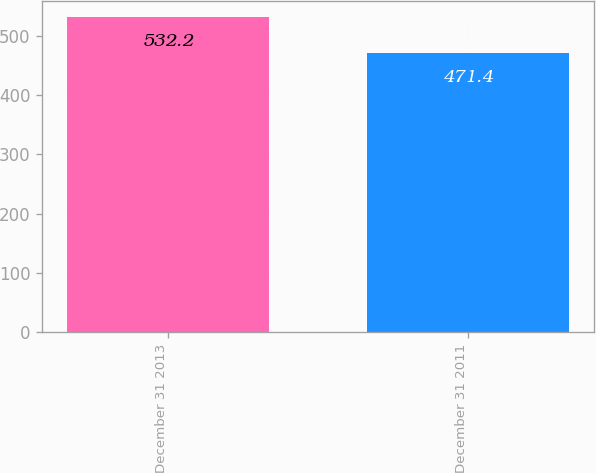<chart> <loc_0><loc_0><loc_500><loc_500><bar_chart><fcel>December 31 2013<fcel>December 31 2011<nl><fcel>532.2<fcel>471.4<nl></chart> 